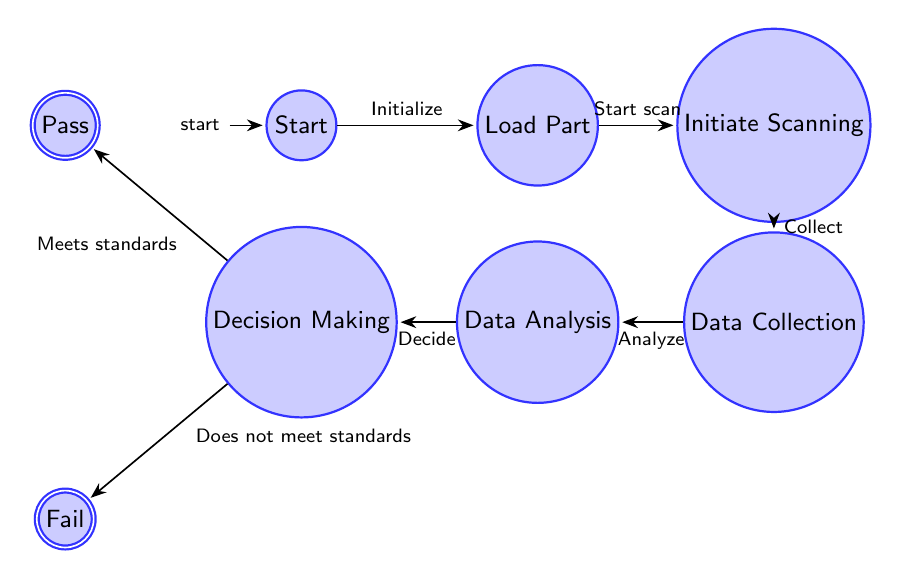What is the initial state in this diagram? The initial state is labeled "Start," which is where the process is initialized before any further actions are taken.
Answer: Start How many states are there in the diagram? There are a total of 8 states, including the initial state and the accepting states. This includes "Start," "Load Part," "Initiate Scanning," "Data Collection," "Data Analysis," "Decision Making," "Pass," and "Fail."
Answer: 8 What happens after "Load Part"? After "Load Part," the process transitions to the "Initiate Scanning" state. This means that once the part is loaded, the next step is to start the scanning process.
Answer: Initiate Scanning If a part does not meet the quality standards, which state does it go to? If a part does not meet the quality standards, it transitions to the "Fail" state, indicating that the inspection did not succeed.
Answer: Fail What is the outcome if the part meets quality standards? If the part meets quality standards, the outcome is that it transitions to the "Pass" state, which implies that it has passed the inspection process and will continue in the production line.
Answer: Pass Which states involve data handling? The states that involve data handling are "Data Collection" where the data is gathered, and "Data Analysis" where that collected data is analyzed for defects.
Answer: Data Collection, Data Analysis What is the relationship between "Decision Making" and "Pass"? The "Decision Making" state has a direct path that leads to the "Pass" state, which signifies that the part has met the required quality standards after analysis.
Answer: Direct path What is the first action that takes place in this process? The first action is labeled as "Initialize," which signifies the start of the inspection process taking place right after the "Start" state is activated.
Answer: Initialize 